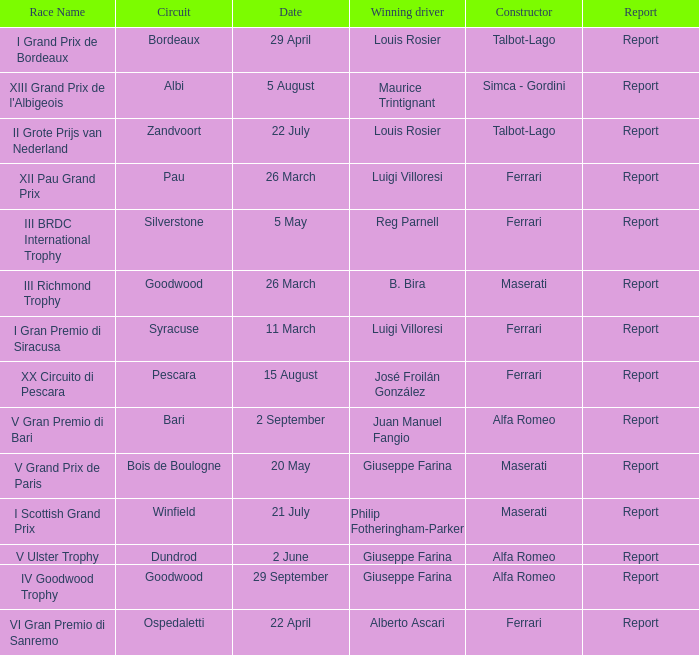Name the report for philip fotheringham-parker Report. 